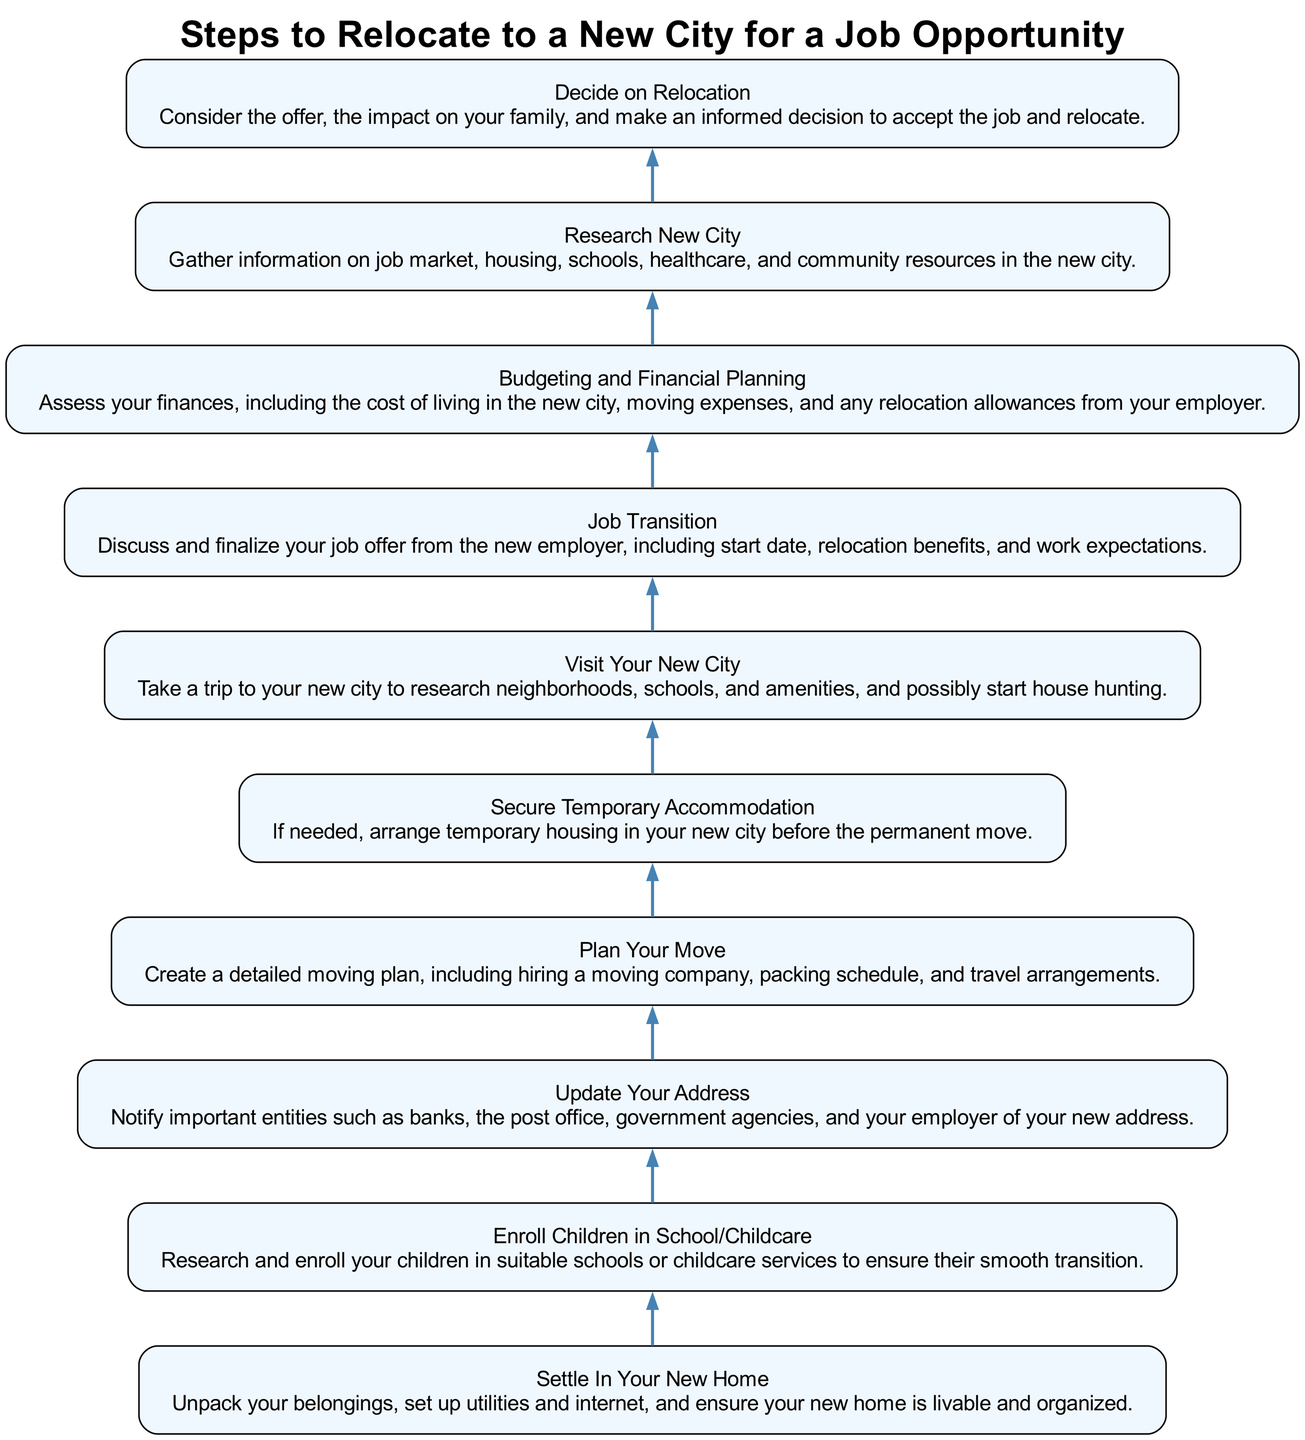What is the first step to undertake after making your relocation decision? The diagram indicates that the first step after deciding to relocate is to transition to your new job. This means finalizing the job offer and discussing key details like start date and relocation benefits.
Answer: Job Transition How many steps are there in the relocation process? By counting the nodes in the diagram, there are ten sequential steps from deciding to relocate through settling into your new home.
Answer: Ten What should be done immediately after settling into your new home? The next step in the diagram after settling into your new home is to enroll children in school or childcare services to support their transition to the new environment.
Answer: Enroll Children in School/Childcare Which step involves financial assessment? The step titled "Budgeting and Financial Planning" specifically addresses assessing finances related to the move, including moving expenses and cost of living in the new city.
Answer: Budgeting and Financial Planning What is necessary to do before planning your move? According to the flow, before planning the move, one should visit the new city. This visit is essential for gathering firsthand information about neighborhoods, schools, and housing options.
Answer: Visit Your New City What is the relationship between "Research New City" and "Job Transition"? The relationship is that "Research New City" comes before "Job Transition" in the flow. Understanding the new city can help inform decisions during the job transition, particularly regarding relocation benefits and accommodations.
Answer: Research New City precedes Job Transition What is the last step in the relocation process? The final step shown in the diagram is to settle into your new home, which involves unpacking and organizing the living space to ensure it is livable and comfortable.
Answer: Settle In Your New Home How is the flow of steps organized in the diagram? The steps are organized in a bottom-to-top flow, indicating a sequential process where each step leads to the next, starting from deciding to relocate at the bottom of the chart and moving upwards towards settling in.
Answer: Bottom to top What should a single parent prioritize when researching a new city? A single parent should prioritize researching suitable schools and childcare services, as this decision impacts not only their job search but also the wellbeing and transition of their children.
Answer: Schools and childcare services 